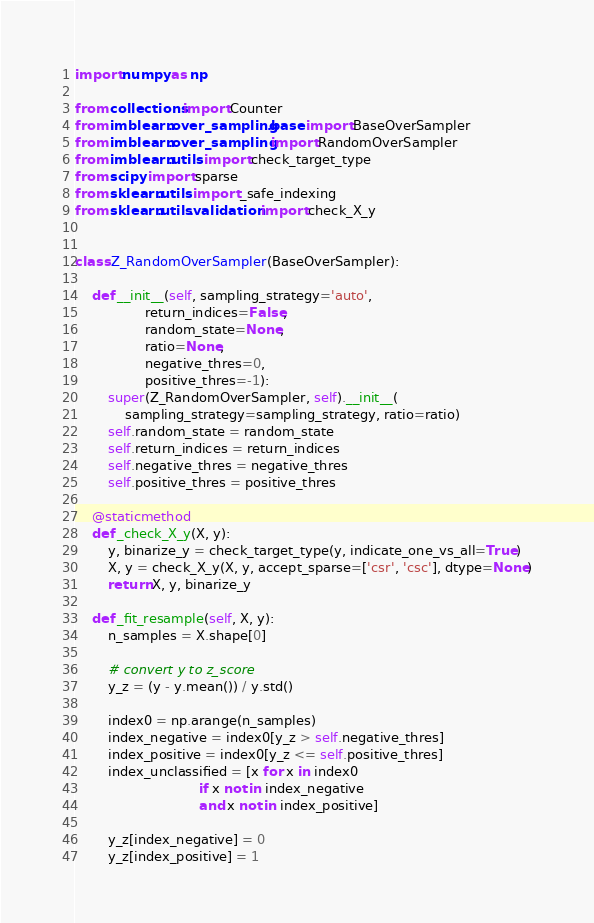<code> <loc_0><loc_0><loc_500><loc_500><_Python_>import numpy as np

from collections import Counter
from imblearn.over_sampling.base import BaseOverSampler
from imblearn.over_sampling import RandomOverSampler
from imblearn.utils import check_target_type
from scipy import sparse
from sklearn.utils import _safe_indexing
from sklearn.utils.validation import check_X_y


class Z_RandomOverSampler(BaseOverSampler):

    def __init__(self, sampling_strategy='auto',
                 return_indices=False,
                 random_state=None,
                 ratio=None,
                 negative_thres=0,
                 positive_thres=-1):
        super(Z_RandomOverSampler, self).__init__(
            sampling_strategy=sampling_strategy, ratio=ratio)
        self.random_state = random_state
        self.return_indices = return_indices
        self.negative_thres = negative_thres
        self.positive_thres = positive_thres

    @staticmethod
    def _check_X_y(X, y):
        y, binarize_y = check_target_type(y, indicate_one_vs_all=True)
        X, y = check_X_y(X, y, accept_sparse=['csr', 'csc'], dtype=None)
        return X, y, binarize_y

    def _fit_resample(self, X, y):
        n_samples = X.shape[0]

        # convert y to z_score
        y_z = (y - y.mean()) / y.std()

        index0 = np.arange(n_samples)
        index_negative = index0[y_z > self.negative_thres]
        index_positive = index0[y_z <= self.positive_thres]
        index_unclassified = [x for x in index0
                              if x not in index_negative
                              and x not in index_positive]

        y_z[index_negative] = 0
        y_z[index_positive] = 1</code> 